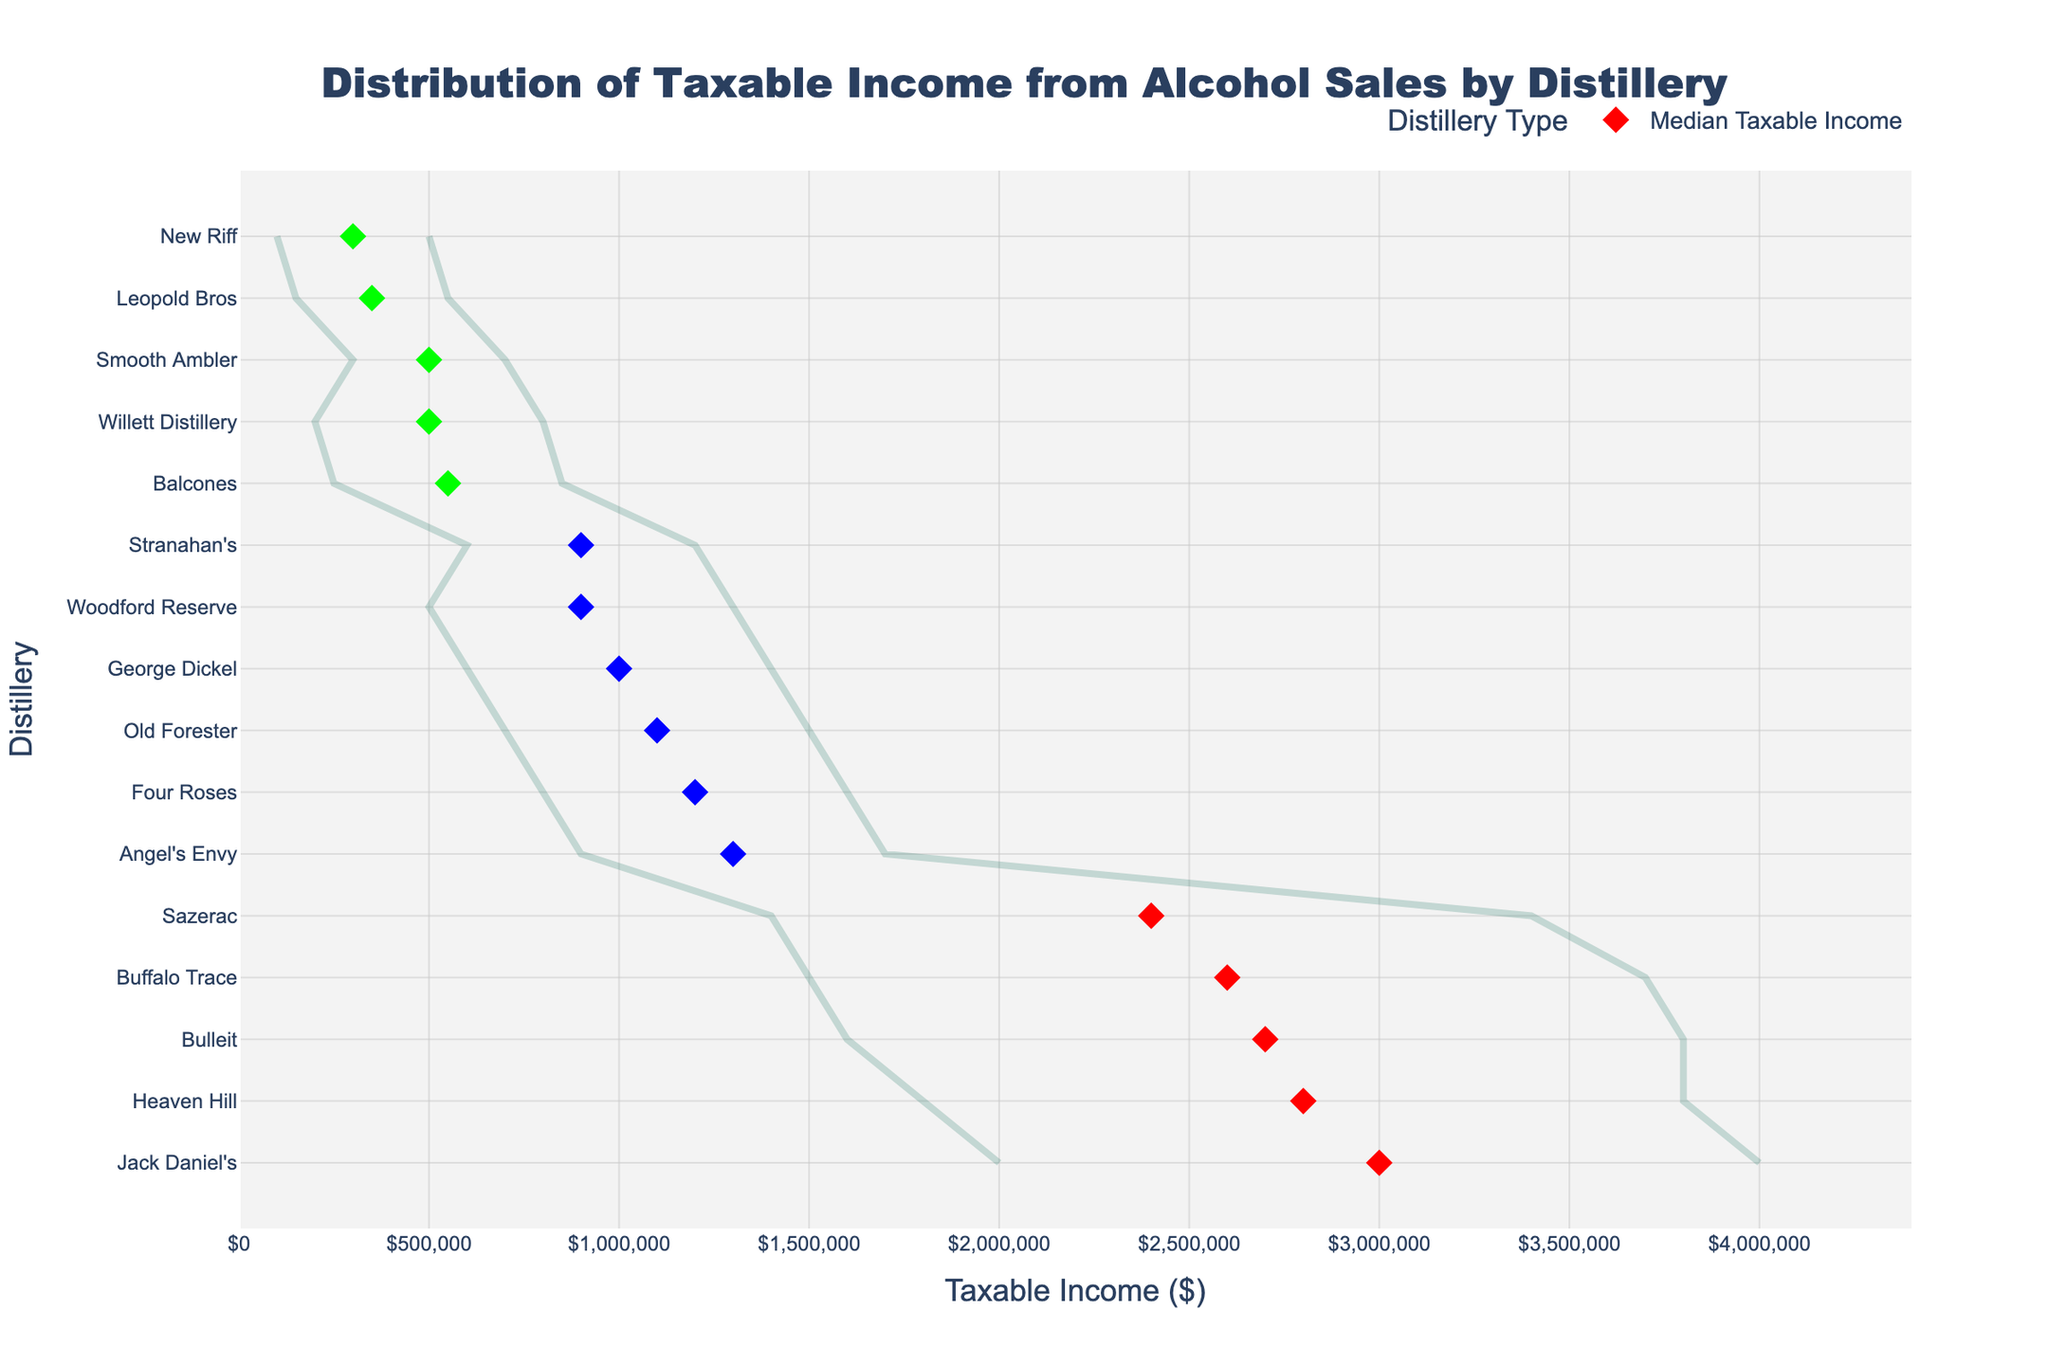What's the title of the figure? The title of the figure is displayed at the top center and describes the overall content of the plot.
Answer: Distribution of Taxable Income from Alcohol Sales by Distillery Which distillery has the maximum taxable income? Locate the distillery with the highest value on the x-axis for taxable income. Jack Daniel's has a maximum taxable income of $4,000,000, the highest on the plot.
Answer: Jack Daniel's What color represents medium-sized distilleries? The color of the median points for medium-sized distilleries needs to be identified in the legend. Medium-sized distilleries use blue color.
Answer: Blue How many distilleries are categorized as large? Count the number of distilleries with median points colored according to large distilleries (red). There are five distilleries marked in red.
Answer: 5 Which distillery has the lowest minimum taxable income? Find the distillery whose range line starts at the lowest value on the x-axis. New Riff, with a minimum taxable income of $100,000, has the lowest.
Answer: New Riff Compare the median taxable income of Woodford Reserve and Four Roses. Which is higher? Check and compare the median taxable income values for Woodford Reserve and Four Roses. Four Roses has a median taxable income of $1,200,000, higher than Woodford Reserve's $900,000.
Answer: Four Roses What's the range of taxable income for Sazerac? Subtract the minimum taxable income from the maximum taxable income for Sazerac. The range for Sazerac is $3,400,000 - $1,400,000 = $2,000,000.
Answer: $2,000,000 Which state has the most distilleries on the plot? Count the number of distilleries from each state listed on the y-axis. Kentucky has the most distilleries, with 8 distilleries shown.
Answer: Kentucky What's the average taxable income for small distilleries? Sum the median taxable income for all small distilleries and divide by the number of small distilleries. ($500,000 + $300,000 + $550,000 + $500,000 + $350,000) / 5 = $440,000.
Answer: $440,000 